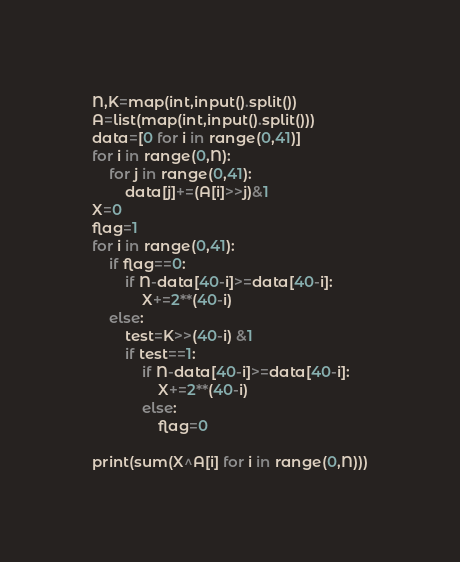Convert code to text. <code><loc_0><loc_0><loc_500><loc_500><_Python_>N,K=map(int,input().split())
A=list(map(int,input().split()))
data=[0 for i in range(0,41)]
for i in range(0,N):
    for j in range(0,41):
        data[j]+=(A[i]>>j)&1
X=0
flag=1
for i in range(0,41):
    if flag==0:
        if N-data[40-i]>=data[40-i]:
            X+=2**(40-i)
    else:
        test=K>>(40-i) &1
        if test==1:
            if N-data[40-i]>=data[40-i]:
                X+=2**(40-i)
            else:
                flag=0

print(sum(X^A[i] for i in range(0,N)))
</code> 